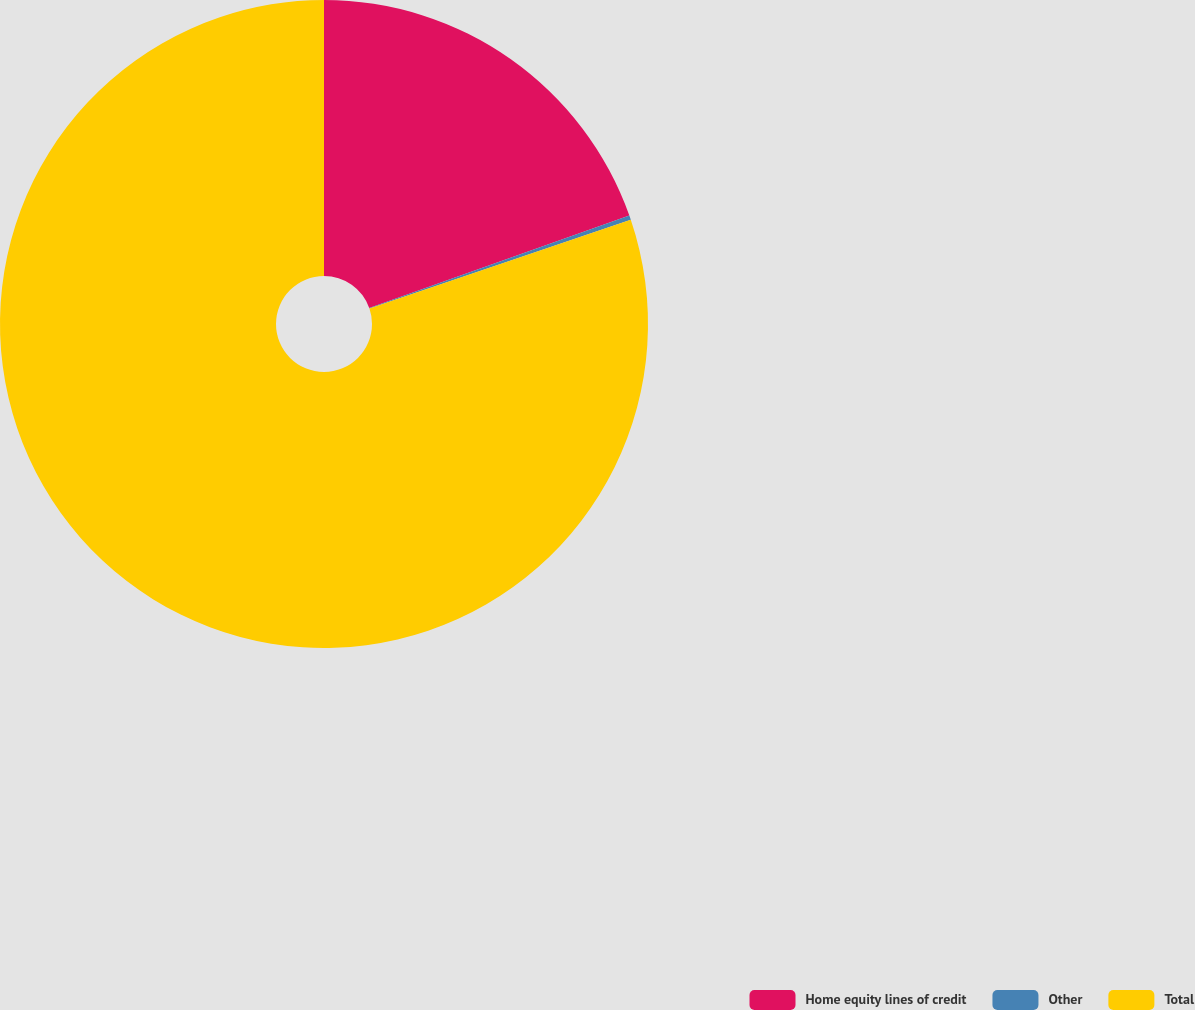Convert chart to OTSL. <chart><loc_0><loc_0><loc_500><loc_500><pie_chart><fcel>Home equity lines of credit<fcel>Other<fcel>Total<nl><fcel>19.57%<fcel>0.22%<fcel>80.21%<nl></chart> 